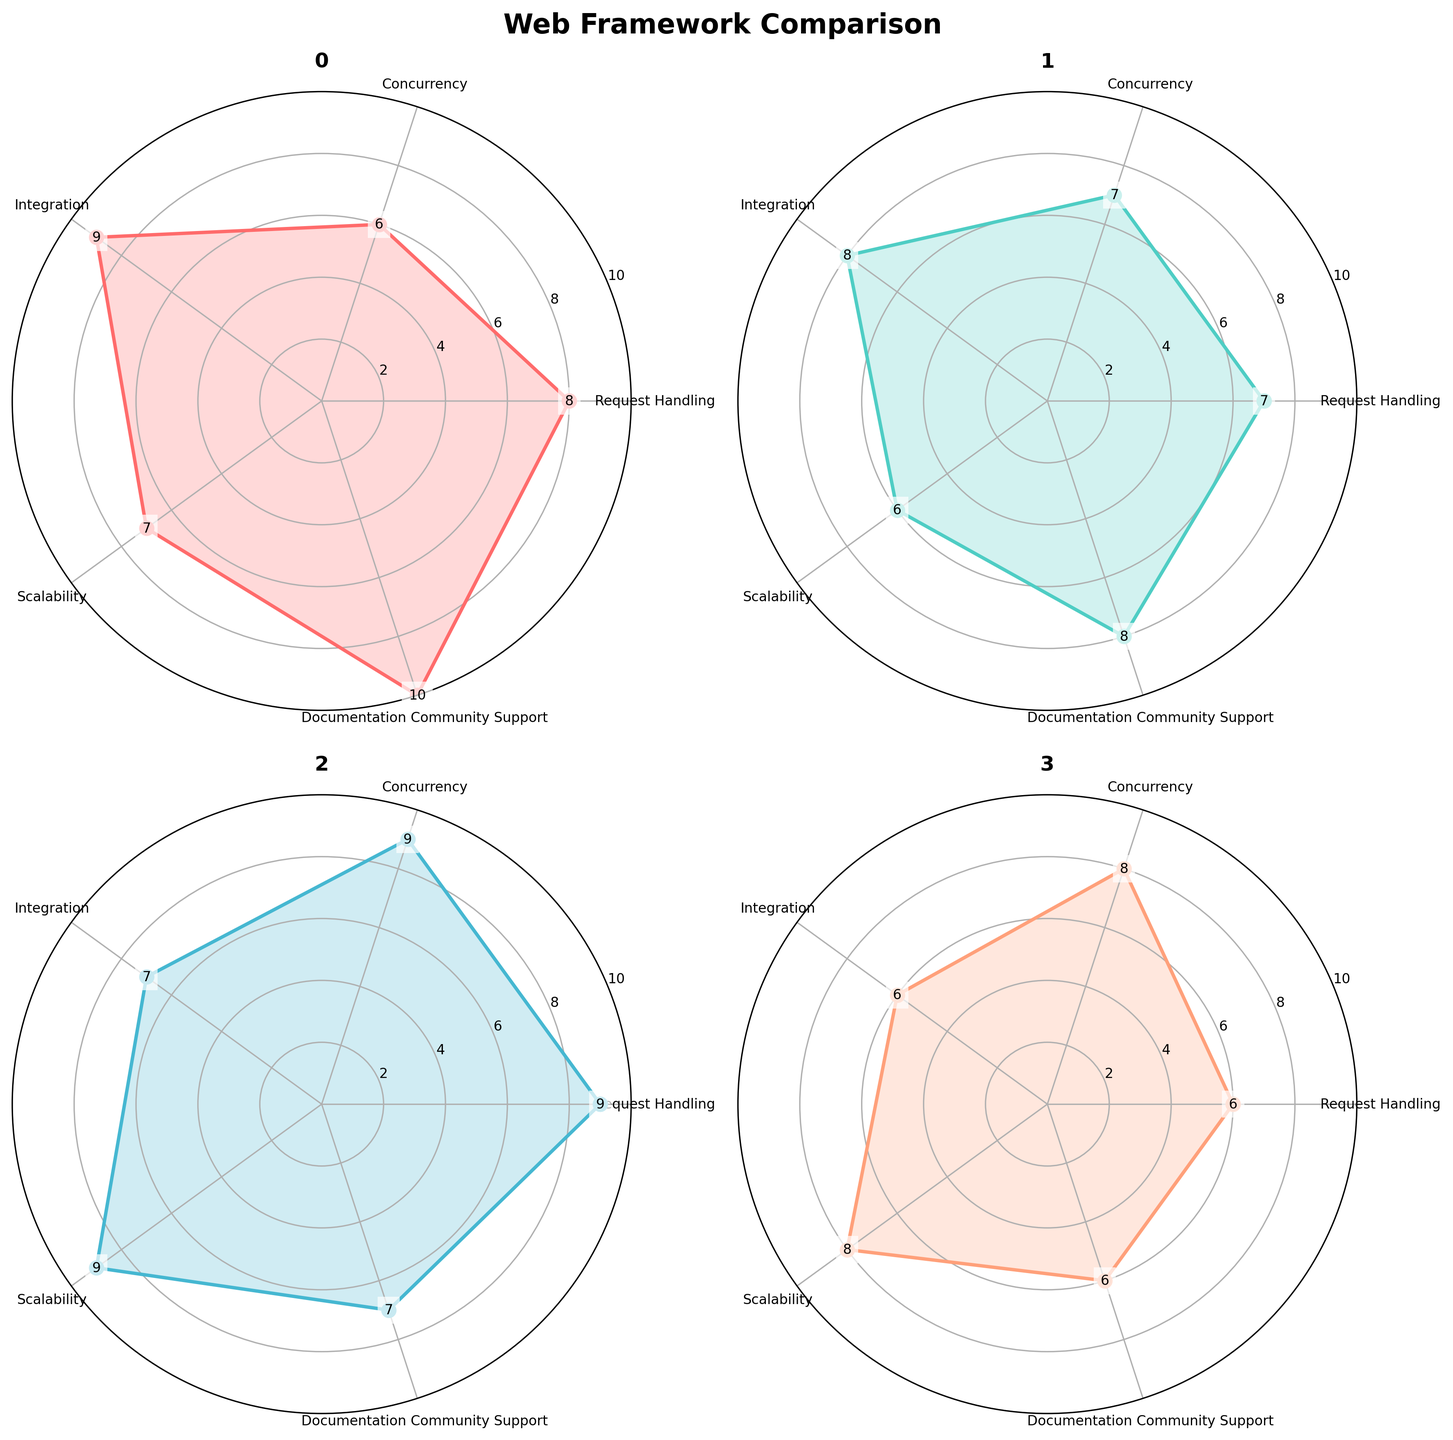Which framework scores the highest in Documentation and Community Support? By looking at the Documentation and Community Support values for all frameworks, Django has the highest score of 10.
Answer: Django Which framework has the lowest score in Scalability? Observing the Scalability scores, Flask has the lowest score with 6.
Answer: Flask How does FastAPI's Request Handling compare to Django's? FastAPI has a score of 9 in Request Handling, while Django has a score of 8, so FastAPI scores higher.
Answer: FastAPI scores higher What is the average Concurrency score for all frameworks? Adding the Concurrency scores: Django (6), Flask (7), FastAPI (9), Tornado (8). The total is 30. Dividing by 4 frameworks, the average is 30 / 4 = 7.5.
Answer: 7.5 Which framework has the largest difference between Request Handling and Integration scores? For Django: 8-9 = -1. For Flask: 7-8 = -1. For FastAPI: 9-7 = 2. For Tornado: 6-6 = 0. FastAPI has the largest absolute difference of 2.
Answer: FastAPI Comparing Django and Flask, which has a better performance in Integration? Django scores 9 in Integration, while Flask scores 8. Therefore, Django scores better.
Answer: Django Which categories do all frameworks excel equally well (score of 6 or above)? Each category from Request Handling, Concurrency, Integration, Scalability, Documentation Community Support scores above 6 for all frameworks.
Answer: All categories Between FastAPI and Tornado, which has more consistent scores across all categories? Calculating the range for each: FastAPI’s range is (9-7) = 2. Tornado’s range is (8-6) = 2. Both frameworks have the same consistency with a range of 2.
Answer: Both are equally consistent What is the average Integration score for Django and Tornado combined? Adding the Integration scores: Django (9) and Tornado (6). The total is 15. Dividing by 2 frameworks, the average is 15 / 2 = 7.5.
Answer: 7.5 